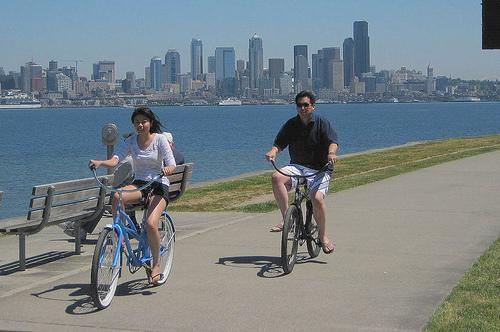How many people are riding bikes?
Give a very brief answer. 2. How many bikes are there?
Give a very brief answer. 2. How many bicycles?
Give a very brief answer. 2. How many types of vehicles with wheels are shown?
Give a very brief answer. 1. How many bikes can be seen?
Give a very brief answer. 2. How many bicycles can you see?
Give a very brief answer. 2. How many people are in the picture?
Give a very brief answer. 2. 